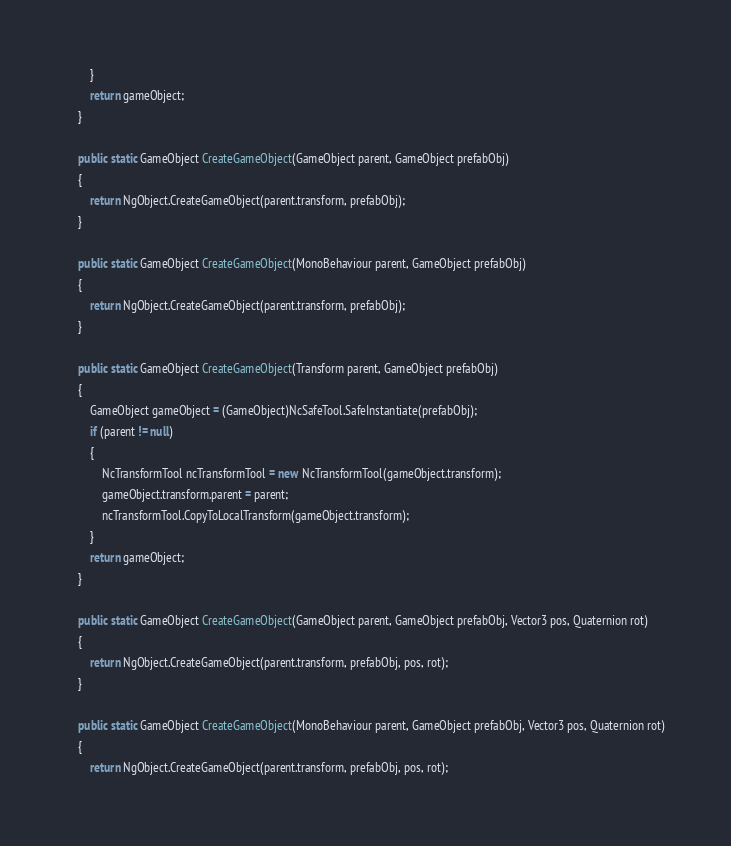Convert code to text. <code><loc_0><loc_0><loc_500><loc_500><_C#_>		}
		return gameObject;
	}

	public static GameObject CreateGameObject(GameObject parent, GameObject prefabObj)
	{
		return NgObject.CreateGameObject(parent.transform, prefabObj);
	}

	public static GameObject CreateGameObject(MonoBehaviour parent, GameObject prefabObj)
	{
		return NgObject.CreateGameObject(parent.transform, prefabObj);
	}

	public static GameObject CreateGameObject(Transform parent, GameObject prefabObj)
	{
		GameObject gameObject = (GameObject)NcSafeTool.SafeInstantiate(prefabObj);
		if (parent != null)
		{
			NcTransformTool ncTransformTool = new NcTransformTool(gameObject.transform);
			gameObject.transform.parent = parent;
			ncTransformTool.CopyToLocalTransform(gameObject.transform);
		}
		return gameObject;
	}

	public static GameObject CreateGameObject(GameObject parent, GameObject prefabObj, Vector3 pos, Quaternion rot)
	{
		return NgObject.CreateGameObject(parent.transform, prefabObj, pos, rot);
	}

	public static GameObject CreateGameObject(MonoBehaviour parent, GameObject prefabObj, Vector3 pos, Quaternion rot)
	{
		return NgObject.CreateGameObject(parent.transform, prefabObj, pos, rot);</code> 